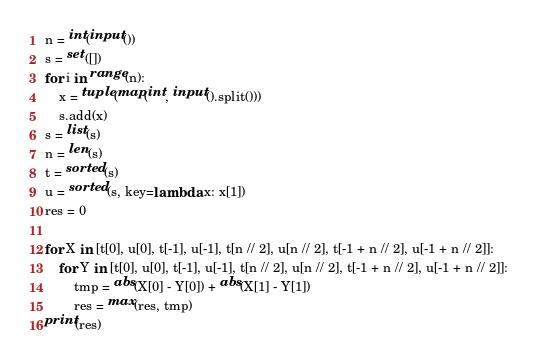Convert code to text. <code><loc_0><loc_0><loc_500><loc_500><_Python_>n = int(input())
s = set([])
for i in range(n):
    x = tuple(map(int, input().split()))
    s.add(x)
s = list(s)
n = len(s)
t = sorted(s)
u = sorted(s, key=lambda x: x[1])
res = 0

for X in [t[0], u[0], t[-1], u[-1], t[n // 2], u[n // 2], t[-1 + n // 2], u[-1 + n // 2]]:
    for Y in [t[0], u[0], t[-1], u[-1], t[n // 2], u[n // 2], t[-1 + n // 2], u[-1 + n // 2]]:
        tmp = abs(X[0] - Y[0]) + abs(X[1] - Y[1])
        res = max(res, tmp)
print(res)

</code> 